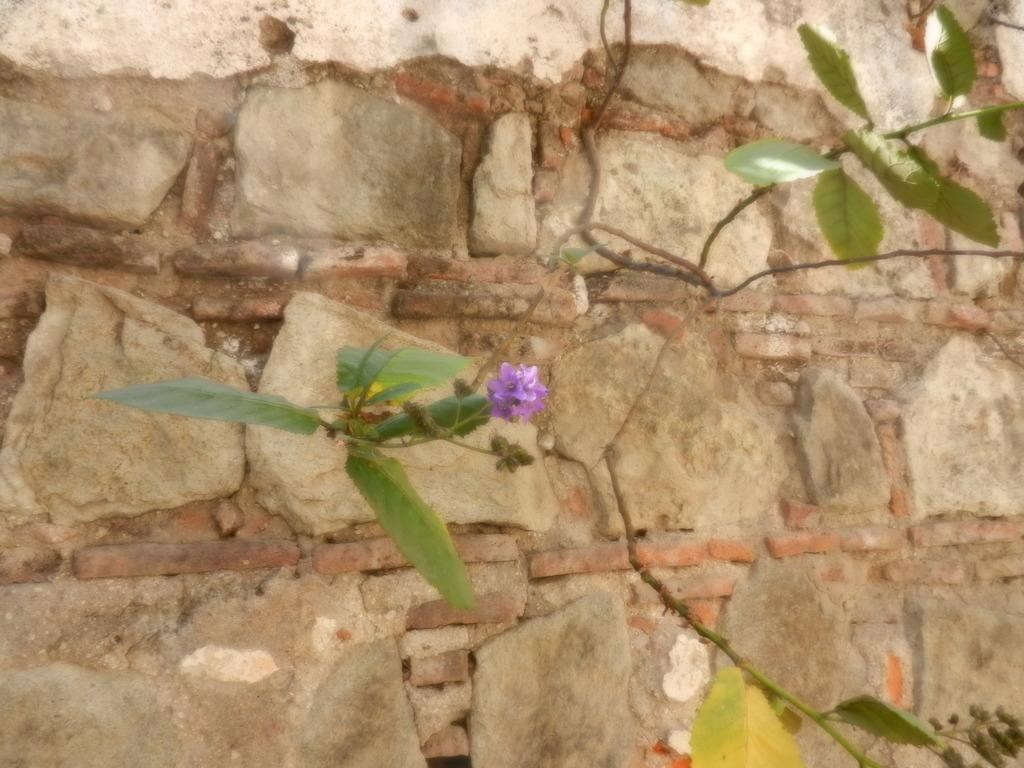What type of vegetation can be seen in the image? There are green color leaves in the image. What is the color of the flower in the image? There is a purple color flower in the image. What can be seen in the background of the image? There is a wall in the background of the image. What type of pleasure can be seen in the image? There is no indication of pleasure in the image; it features green leaves, a purple flower, and a wall in the background. How many beads are present in the image? There are no beads present in the image. 